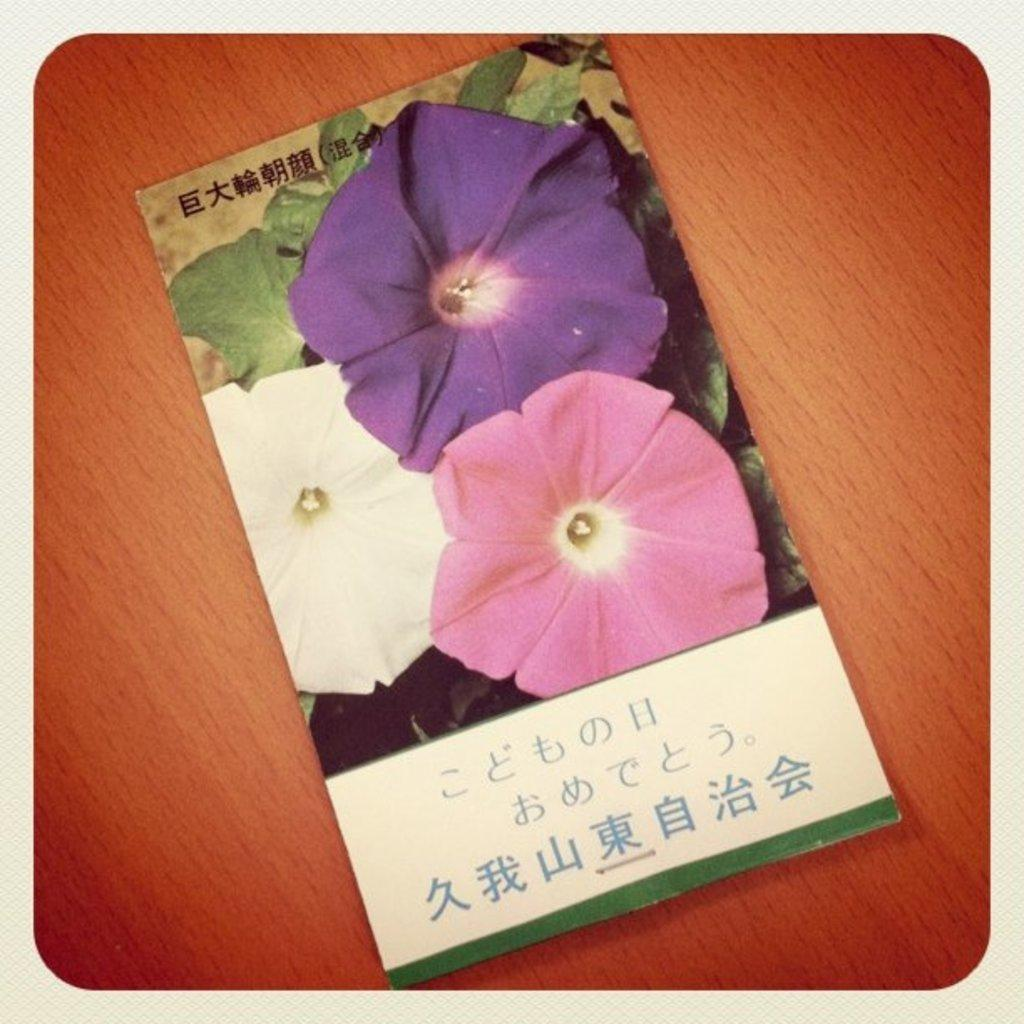What can be observed about the image itself? The image is edited. What object is present in the image? There is a book in the image. Where is the book located? The book is on a wooden plank. What can be found on the pages of the book? The book has text on it and images of flowers. Can you see any mice running along the coast in the image? There are no mice or coast visible in the image; it features a book on a wooden plank with text and images of flowers. 